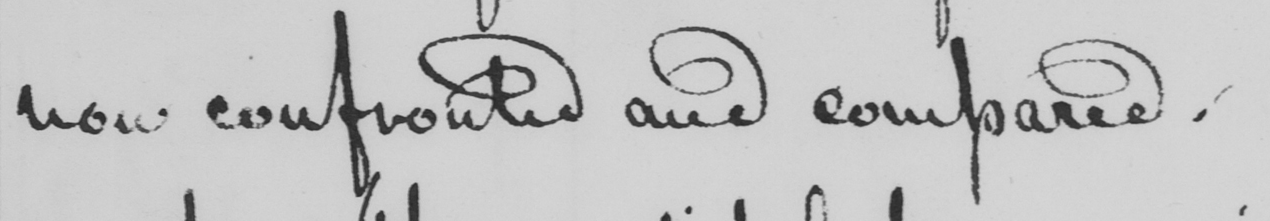Can you read and transcribe this handwriting? now confronted and compared . 